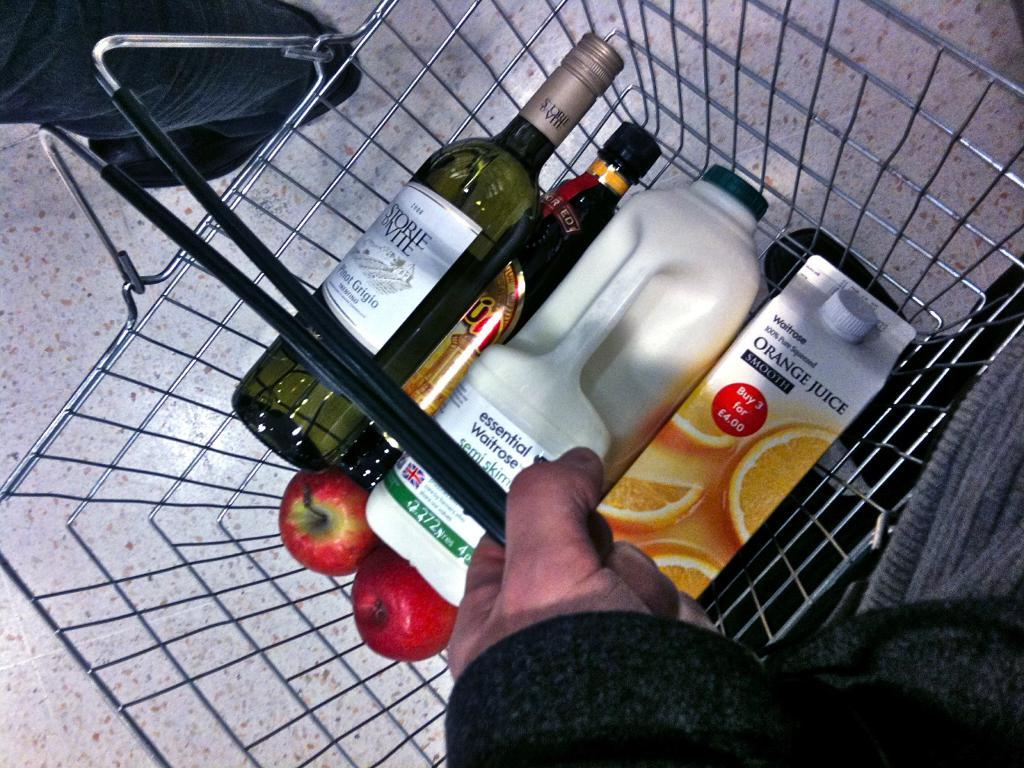<image>
Render a clear and concise summary of the photo. someone is buying orange juice, wine, apples and other things 